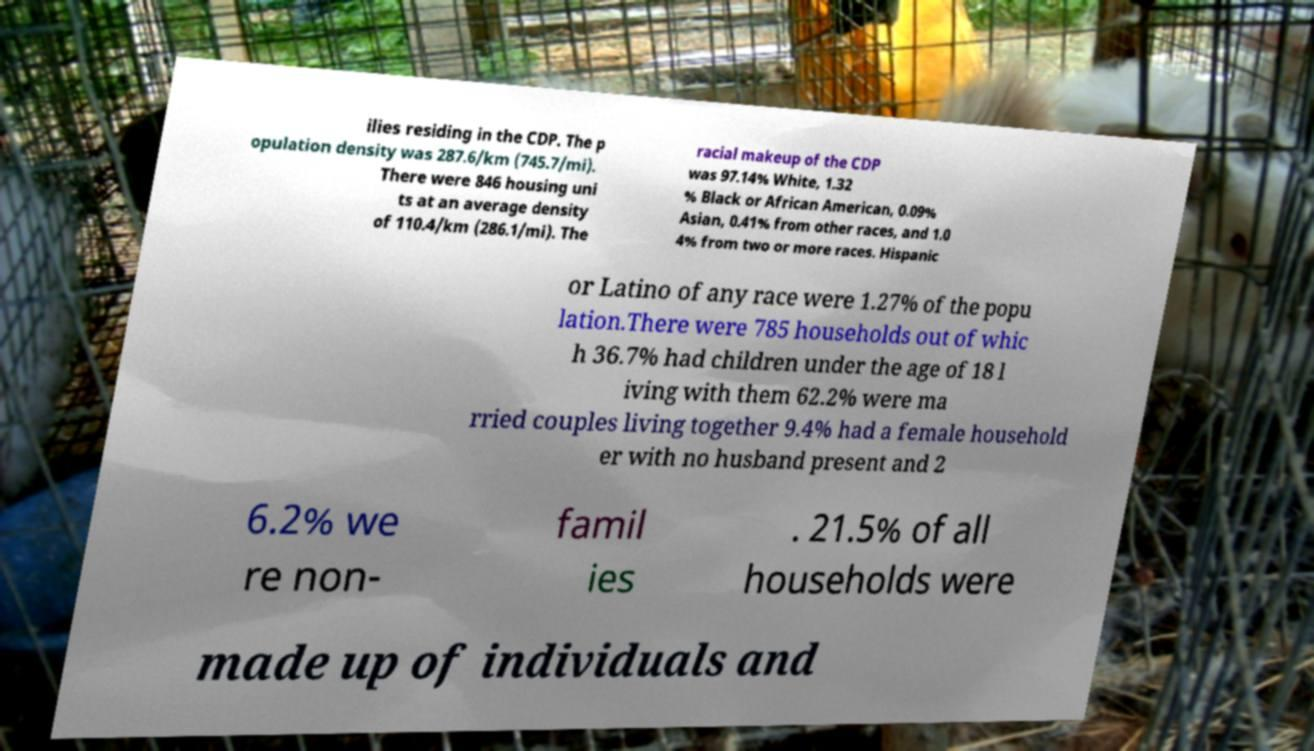Can you accurately transcribe the text from the provided image for me? ilies residing in the CDP. The p opulation density was 287.6/km (745.7/mi). There were 846 housing uni ts at an average density of 110.4/km (286.1/mi). The racial makeup of the CDP was 97.14% White, 1.32 % Black or African American, 0.09% Asian, 0.41% from other races, and 1.0 4% from two or more races. Hispanic or Latino of any race were 1.27% of the popu lation.There were 785 households out of whic h 36.7% had children under the age of 18 l iving with them 62.2% were ma rried couples living together 9.4% had a female household er with no husband present and 2 6.2% we re non- famil ies . 21.5% of all households were made up of individuals and 